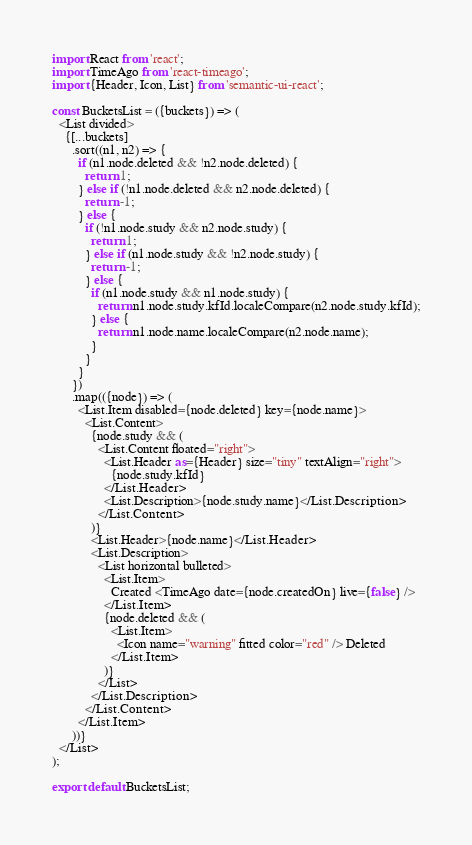<code> <loc_0><loc_0><loc_500><loc_500><_JavaScript_>import React from 'react';
import TimeAgo from 'react-timeago';
import {Header, Icon, List} from 'semantic-ui-react';

const BucketsList = ({buckets}) => (
  <List divided>
    {[...buckets]
      .sort((n1, n2) => {
        if (n1.node.deleted && !n2.node.deleted) {
          return 1;
        } else if (!n1.node.deleted && n2.node.deleted) {
          return -1;
        } else {
          if (!n1.node.study && n2.node.study) {
            return 1;
          } else if (n1.node.study && !n2.node.study) {
            return -1;
          } else {
            if (n1.node.study && n1.node.study) {
              return n1.node.study.kfId.localeCompare(n2.node.study.kfId);
            } else {
              return n1.node.name.localeCompare(n2.node.name);
            }
          }
        }
      })
      .map(({node}) => (
        <List.Item disabled={node.deleted} key={node.name}>
          <List.Content>
            {node.study && (
              <List.Content floated="right">
                <List.Header as={Header} size="tiny" textAlign="right">
                  {node.study.kfId}
                </List.Header>
                <List.Description>{node.study.name}</List.Description>
              </List.Content>
            )}
            <List.Header>{node.name}</List.Header>
            <List.Description>
              <List horizontal bulleted>
                <List.Item>
                  Created <TimeAgo date={node.createdOn} live={false} />
                </List.Item>
                {node.deleted && (
                  <List.Item>
                    <Icon name="warning" fitted color="red" /> Deleted
                  </List.Item>
                )}
              </List>
            </List.Description>
          </List.Content>
        </List.Item>
      ))}
  </List>
);

export default BucketsList;
</code> 